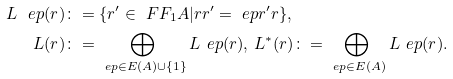<formula> <loc_0><loc_0><loc_500><loc_500>\L L _ { \ } e p ( r ) & \colon = \{ r ^ { \prime } \in \ F F _ { 1 } A | r r ^ { \prime } = \ e p r ^ { \prime } r \} , \\ \L L ( r ) & \colon = \bigoplus _ { \ e p \in E ( A ) \cup \{ 1 \} } \L L _ { \ } e p ( r ) , \, \L L ^ { * } ( r ) \colon = \bigoplus _ { \ e p \in E ( A ) } \L L _ { \ } e p ( r ) .</formula> 